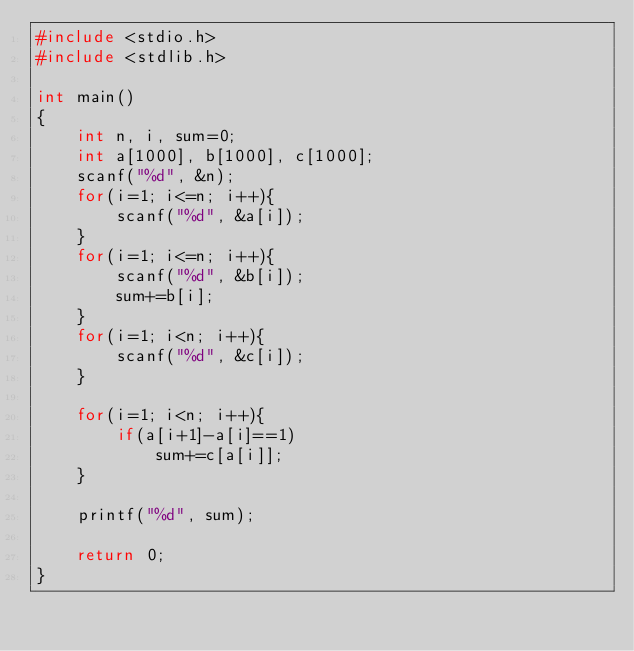Convert code to text. <code><loc_0><loc_0><loc_500><loc_500><_C_>#include <stdio.h>
#include <stdlib.h>

int main()
{
    int n, i, sum=0;
    int a[1000], b[1000], c[1000];
    scanf("%d", &n);
    for(i=1; i<=n; i++){
		scanf("%d", &a[i]);
    }
    for(i=1; i<=n; i++){
		scanf("%d", &b[i]);
		sum+=b[i];
    }
    for(i=1; i<n; i++){
		scanf("%d", &c[i]);
    }

    for(i=1; i<n; i++){
		if(a[i+1]-a[i]==1)
			sum+=c[a[i]];
    }

    printf("%d", sum);

    return 0;
}
</code> 